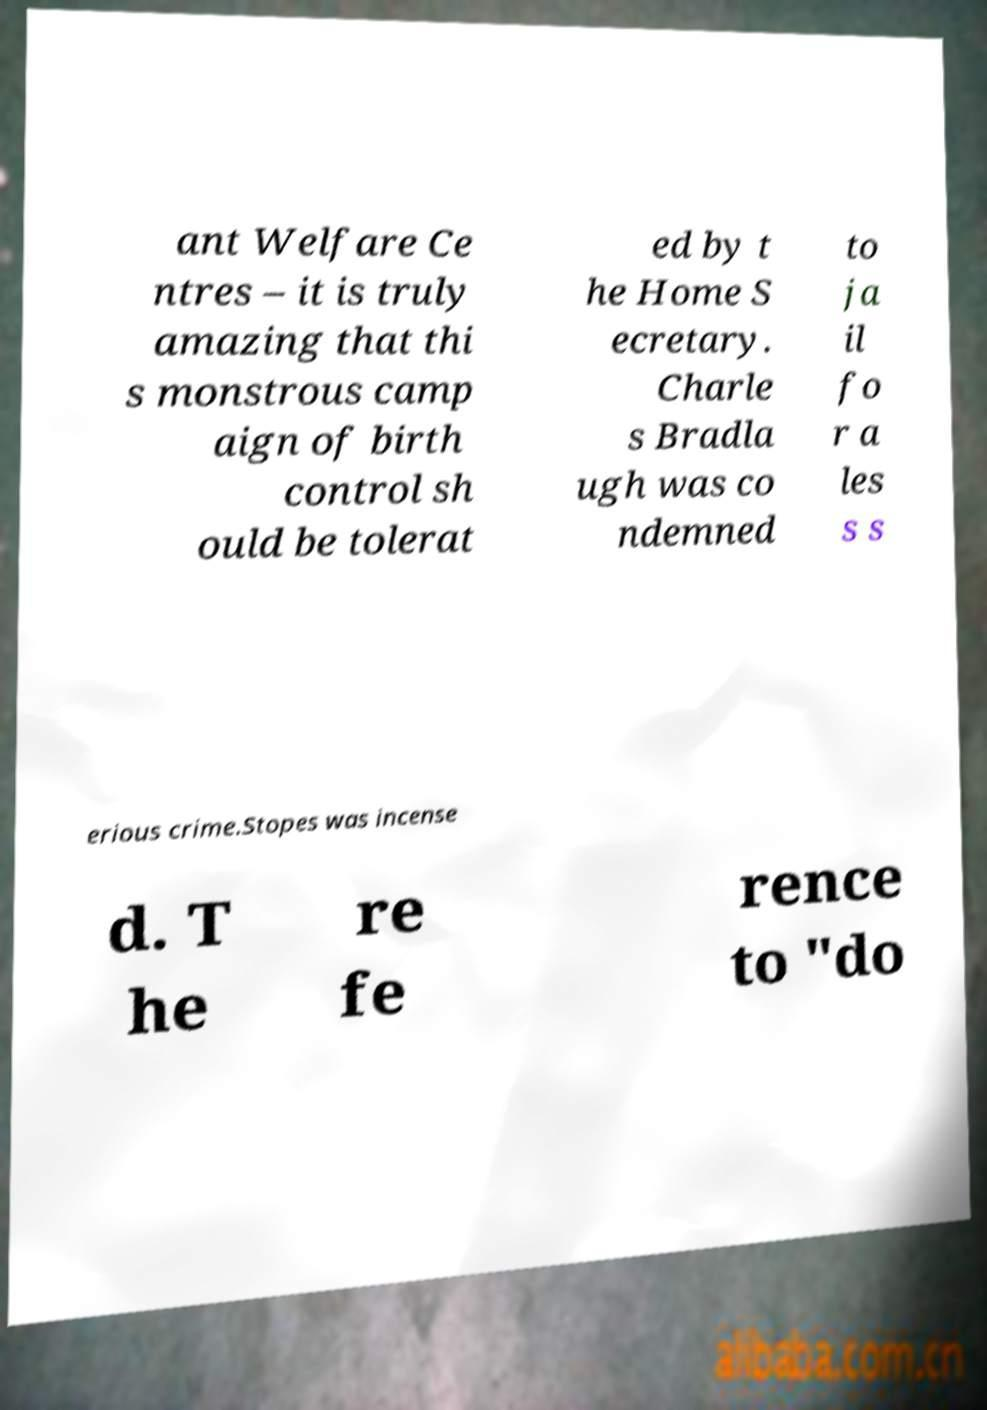Can you read and provide the text displayed in the image?This photo seems to have some interesting text. Can you extract and type it out for me? ant Welfare Ce ntres – it is truly amazing that thi s monstrous camp aign of birth control sh ould be tolerat ed by t he Home S ecretary. Charle s Bradla ugh was co ndemned to ja il fo r a les s s erious crime.Stopes was incense d. T he re fe rence to "do 